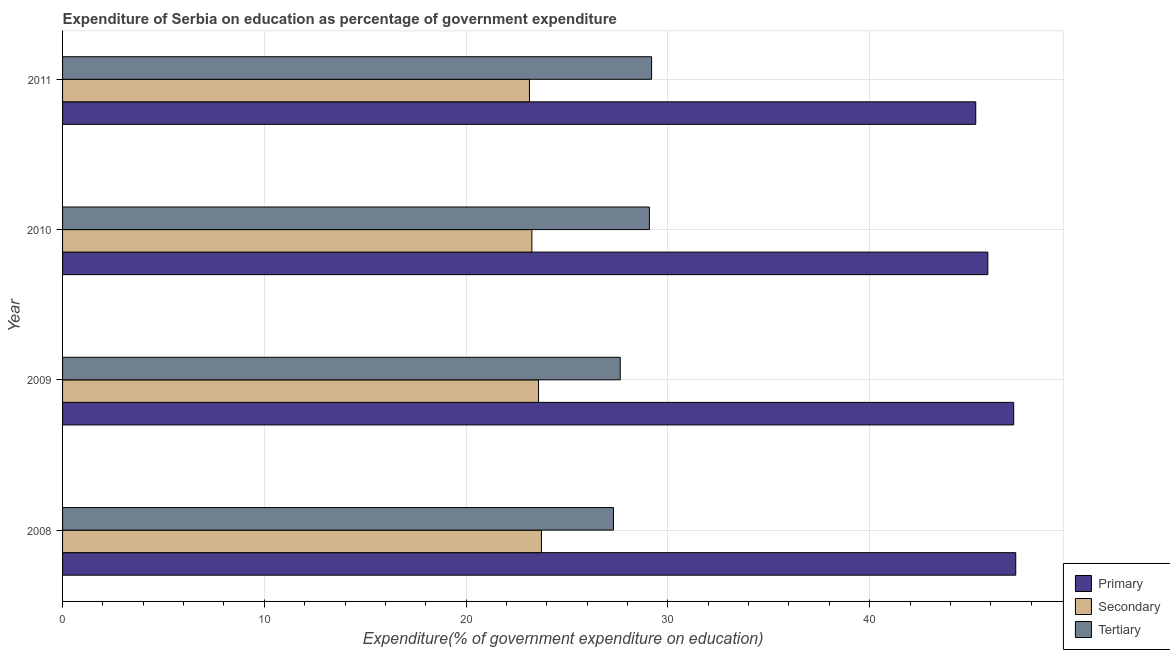How many different coloured bars are there?
Offer a terse response. 3. Are the number of bars per tick equal to the number of legend labels?
Keep it short and to the point. Yes. Are the number of bars on each tick of the Y-axis equal?
Ensure brevity in your answer.  Yes. How many bars are there on the 2nd tick from the top?
Ensure brevity in your answer.  3. How many bars are there on the 2nd tick from the bottom?
Your answer should be very brief. 3. In how many cases, is the number of bars for a given year not equal to the number of legend labels?
Your answer should be very brief. 0. What is the expenditure on tertiary education in 2008?
Your answer should be very brief. 27.3. Across all years, what is the maximum expenditure on tertiary education?
Provide a succinct answer. 29.19. Across all years, what is the minimum expenditure on secondary education?
Offer a terse response. 23.14. In which year was the expenditure on secondary education minimum?
Your response must be concise. 2011. What is the total expenditure on tertiary education in the graph?
Make the answer very short. 113.21. What is the difference between the expenditure on secondary education in 2009 and that in 2011?
Your answer should be very brief. 0.45. What is the difference between the expenditure on tertiary education in 2008 and the expenditure on secondary education in 2011?
Provide a succinct answer. 4.16. What is the average expenditure on tertiary education per year?
Offer a terse response. 28.3. In the year 2009, what is the difference between the expenditure on primary education and expenditure on secondary education?
Give a very brief answer. 23.55. What is the ratio of the expenditure on primary education in 2010 to that in 2011?
Your answer should be compact. 1.01. Is the expenditure on secondary education in 2008 less than that in 2009?
Offer a very short reply. No. What is the difference between the highest and the second highest expenditure on secondary education?
Give a very brief answer. 0.14. What is the difference between the highest and the lowest expenditure on tertiary education?
Offer a very short reply. 1.89. What does the 1st bar from the top in 2011 represents?
Your answer should be very brief. Tertiary. What does the 3rd bar from the bottom in 2010 represents?
Ensure brevity in your answer.  Tertiary. Is it the case that in every year, the sum of the expenditure on primary education and expenditure on secondary education is greater than the expenditure on tertiary education?
Provide a short and direct response. Yes. Are all the bars in the graph horizontal?
Provide a short and direct response. Yes. Does the graph contain any zero values?
Give a very brief answer. No. Does the graph contain grids?
Your response must be concise. Yes. Where does the legend appear in the graph?
Give a very brief answer. Bottom right. How many legend labels are there?
Give a very brief answer. 3. How are the legend labels stacked?
Offer a terse response. Vertical. What is the title of the graph?
Provide a succinct answer. Expenditure of Serbia on education as percentage of government expenditure. What is the label or title of the X-axis?
Your answer should be compact. Expenditure(% of government expenditure on education). What is the label or title of the Y-axis?
Your answer should be very brief. Year. What is the Expenditure(% of government expenditure on education) of Primary in 2008?
Provide a succinct answer. 47.24. What is the Expenditure(% of government expenditure on education) in Secondary in 2008?
Your response must be concise. 23.73. What is the Expenditure(% of government expenditure on education) of Tertiary in 2008?
Make the answer very short. 27.3. What is the Expenditure(% of government expenditure on education) in Primary in 2009?
Give a very brief answer. 47.14. What is the Expenditure(% of government expenditure on education) of Secondary in 2009?
Make the answer very short. 23.59. What is the Expenditure(% of government expenditure on education) in Tertiary in 2009?
Make the answer very short. 27.64. What is the Expenditure(% of government expenditure on education) in Primary in 2010?
Provide a short and direct response. 45.86. What is the Expenditure(% of government expenditure on education) in Secondary in 2010?
Provide a succinct answer. 23.26. What is the Expenditure(% of government expenditure on education) in Tertiary in 2010?
Your response must be concise. 29.08. What is the Expenditure(% of government expenditure on education) in Primary in 2011?
Make the answer very short. 45.26. What is the Expenditure(% of government expenditure on education) in Secondary in 2011?
Give a very brief answer. 23.14. What is the Expenditure(% of government expenditure on education) of Tertiary in 2011?
Your answer should be compact. 29.19. Across all years, what is the maximum Expenditure(% of government expenditure on education) in Primary?
Give a very brief answer. 47.24. Across all years, what is the maximum Expenditure(% of government expenditure on education) of Secondary?
Ensure brevity in your answer.  23.73. Across all years, what is the maximum Expenditure(% of government expenditure on education) in Tertiary?
Provide a succinct answer. 29.19. Across all years, what is the minimum Expenditure(% of government expenditure on education) of Primary?
Ensure brevity in your answer.  45.26. Across all years, what is the minimum Expenditure(% of government expenditure on education) in Secondary?
Make the answer very short. 23.14. Across all years, what is the minimum Expenditure(% of government expenditure on education) of Tertiary?
Give a very brief answer. 27.3. What is the total Expenditure(% of government expenditure on education) in Primary in the graph?
Ensure brevity in your answer.  185.49. What is the total Expenditure(% of government expenditure on education) of Secondary in the graph?
Ensure brevity in your answer.  93.72. What is the total Expenditure(% of government expenditure on education) of Tertiary in the graph?
Your response must be concise. 113.21. What is the difference between the Expenditure(% of government expenditure on education) in Primary in 2008 and that in 2009?
Offer a very short reply. 0.1. What is the difference between the Expenditure(% of government expenditure on education) in Secondary in 2008 and that in 2009?
Provide a succinct answer. 0.14. What is the difference between the Expenditure(% of government expenditure on education) in Tertiary in 2008 and that in 2009?
Your answer should be compact. -0.34. What is the difference between the Expenditure(% of government expenditure on education) of Primary in 2008 and that in 2010?
Your answer should be compact. 1.38. What is the difference between the Expenditure(% of government expenditure on education) in Secondary in 2008 and that in 2010?
Provide a succinct answer. 0.47. What is the difference between the Expenditure(% of government expenditure on education) of Tertiary in 2008 and that in 2010?
Provide a short and direct response. -1.78. What is the difference between the Expenditure(% of government expenditure on education) in Primary in 2008 and that in 2011?
Give a very brief answer. 1.98. What is the difference between the Expenditure(% of government expenditure on education) in Secondary in 2008 and that in 2011?
Provide a succinct answer. 0.59. What is the difference between the Expenditure(% of government expenditure on education) in Tertiary in 2008 and that in 2011?
Your answer should be very brief. -1.89. What is the difference between the Expenditure(% of government expenditure on education) in Primary in 2009 and that in 2010?
Provide a succinct answer. 1.28. What is the difference between the Expenditure(% of government expenditure on education) in Secondary in 2009 and that in 2010?
Your response must be concise. 0.33. What is the difference between the Expenditure(% of government expenditure on education) in Tertiary in 2009 and that in 2010?
Keep it short and to the point. -1.44. What is the difference between the Expenditure(% of government expenditure on education) of Primary in 2009 and that in 2011?
Provide a succinct answer. 1.88. What is the difference between the Expenditure(% of government expenditure on education) of Secondary in 2009 and that in 2011?
Offer a very short reply. 0.45. What is the difference between the Expenditure(% of government expenditure on education) of Tertiary in 2009 and that in 2011?
Your answer should be very brief. -1.55. What is the difference between the Expenditure(% of government expenditure on education) in Primary in 2010 and that in 2011?
Your answer should be very brief. 0.6. What is the difference between the Expenditure(% of government expenditure on education) in Secondary in 2010 and that in 2011?
Provide a short and direct response. 0.12. What is the difference between the Expenditure(% of government expenditure on education) of Tertiary in 2010 and that in 2011?
Provide a succinct answer. -0.11. What is the difference between the Expenditure(% of government expenditure on education) in Primary in 2008 and the Expenditure(% of government expenditure on education) in Secondary in 2009?
Provide a short and direct response. 23.65. What is the difference between the Expenditure(% of government expenditure on education) of Primary in 2008 and the Expenditure(% of government expenditure on education) of Tertiary in 2009?
Keep it short and to the point. 19.6. What is the difference between the Expenditure(% of government expenditure on education) of Secondary in 2008 and the Expenditure(% of government expenditure on education) of Tertiary in 2009?
Your answer should be very brief. -3.91. What is the difference between the Expenditure(% of government expenditure on education) in Primary in 2008 and the Expenditure(% of government expenditure on education) in Secondary in 2010?
Offer a very short reply. 23.98. What is the difference between the Expenditure(% of government expenditure on education) in Primary in 2008 and the Expenditure(% of government expenditure on education) in Tertiary in 2010?
Make the answer very short. 18.16. What is the difference between the Expenditure(% of government expenditure on education) of Secondary in 2008 and the Expenditure(% of government expenditure on education) of Tertiary in 2010?
Offer a very short reply. -5.35. What is the difference between the Expenditure(% of government expenditure on education) of Primary in 2008 and the Expenditure(% of government expenditure on education) of Secondary in 2011?
Your response must be concise. 24.1. What is the difference between the Expenditure(% of government expenditure on education) in Primary in 2008 and the Expenditure(% of government expenditure on education) in Tertiary in 2011?
Ensure brevity in your answer.  18.05. What is the difference between the Expenditure(% of government expenditure on education) of Secondary in 2008 and the Expenditure(% of government expenditure on education) of Tertiary in 2011?
Give a very brief answer. -5.46. What is the difference between the Expenditure(% of government expenditure on education) in Primary in 2009 and the Expenditure(% of government expenditure on education) in Secondary in 2010?
Provide a succinct answer. 23.88. What is the difference between the Expenditure(% of government expenditure on education) in Primary in 2009 and the Expenditure(% of government expenditure on education) in Tertiary in 2010?
Give a very brief answer. 18.05. What is the difference between the Expenditure(% of government expenditure on education) of Secondary in 2009 and the Expenditure(% of government expenditure on education) of Tertiary in 2010?
Offer a terse response. -5.49. What is the difference between the Expenditure(% of government expenditure on education) of Primary in 2009 and the Expenditure(% of government expenditure on education) of Secondary in 2011?
Offer a very short reply. 24. What is the difference between the Expenditure(% of government expenditure on education) of Primary in 2009 and the Expenditure(% of government expenditure on education) of Tertiary in 2011?
Offer a very short reply. 17.95. What is the difference between the Expenditure(% of government expenditure on education) in Secondary in 2009 and the Expenditure(% of government expenditure on education) in Tertiary in 2011?
Your answer should be compact. -5.6. What is the difference between the Expenditure(% of government expenditure on education) in Primary in 2010 and the Expenditure(% of government expenditure on education) in Secondary in 2011?
Your answer should be very brief. 22.72. What is the difference between the Expenditure(% of government expenditure on education) in Primary in 2010 and the Expenditure(% of government expenditure on education) in Tertiary in 2011?
Your answer should be compact. 16.66. What is the difference between the Expenditure(% of government expenditure on education) in Secondary in 2010 and the Expenditure(% of government expenditure on education) in Tertiary in 2011?
Offer a very short reply. -5.93. What is the average Expenditure(% of government expenditure on education) of Primary per year?
Ensure brevity in your answer.  46.37. What is the average Expenditure(% of government expenditure on education) in Secondary per year?
Keep it short and to the point. 23.43. What is the average Expenditure(% of government expenditure on education) in Tertiary per year?
Keep it short and to the point. 28.3. In the year 2008, what is the difference between the Expenditure(% of government expenditure on education) in Primary and Expenditure(% of government expenditure on education) in Secondary?
Your answer should be compact. 23.51. In the year 2008, what is the difference between the Expenditure(% of government expenditure on education) in Primary and Expenditure(% of government expenditure on education) in Tertiary?
Your response must be concise. 19.94. In the year 2008, what is the difference between the Expenditure(% of government expenditure on education) in Secondary and Expenditure(% of government expenditure on education) in Tertiary?
Offer a terse response. -3.57. In the year 2009, what is the difference between the Expenditure(% of government expenditure on education) of Primary and Expenditure(% of government expenditure on education) of Secondary?
Ensure brevity in your answer.  23.55. In the year 2009, what is the difference between the Expenditure(% of government expenditure on education) in Primary and Expenditure(% of government expenditure on education) in Tertiary?
Give a very brief answer. 19.5. In the year 2009, what is the difference between the Expenditure(% of government expenditure on education) of Secondary and Expenditure(% of government expenditure on education) of Tertiary?
Keep it short and to the point. -4.05. In the year 2010, what is the difference between the Expenditure(% of government expenditure on education) in Primary and Expenditure(% of government expenditure on education) in Secondary?
Offer a very short reply. 22.6. In the year 2010, what is the difference between the Expenditure(% of government expenditure on education) in Primary and Expenditure(% of government expenditure on education) in Tertiary?
Provide a short and direct response. 16.77. In the year 2010, what is the difference between the Expenditure(% of government expenditure on education) in Secondary and Expenditure(% of government expenditure on education) in Tertiary?
Give a very brief answer. -5.82. In the year 2011, what is the difference between the Expenditure(% of government expenditure on education) in Primary and Expenditure(% of government expenditure on education) in Secondary?
Your answer should be very brief. 22.12. In the year 2011, what is the difference between the Expenditure(% of government expenditure on education) of Primary and Expenditure(% of government expenditure on education) of Tertiary?
Your response must be concise. 16.07. In the year 2011, what is the difference between the Expenditure(% of government expenditure on education) in Secondary and Expenditure(% of government expenditure on education) in Tertiary?
Keep it short and to the point. -6.05. What is the ratio of the Expenditure(% of government expenditure on education) of Primary in 2008 to that in 2009?
Give a very brief answer. 1. What is the ratio of the Expenditure(% of government expenditure on education) of Primary in 2008 to that in 2010?
Provide a succinct answer. 1.03. What is the ratio of the Expenditure(% of government expenditure on education) of Secondary in 2008 to that in 2010?
Your answer should be very brief. 1.02. What is the ratio of the Expenditure(% of government expenditure on education) of Tertiary in 2008 to that in 2010?
Offer a very short reply. 0.94. What is the ratio of the Expenditure(% of government expenditure on education) in Primary in 2008 to that in 2011?
Your answer should be very brief. 1.04. What is the ratio of the Expenditure(% of government expenditure on education) of Secondary in 2008 to that in 2011?
Make the answer very short. 1.03. What is the ratio of the Expenditure(% of government expenditure on education) in Tertiary in 2008 to that in 2011?
Ensure brevity in your answer.  0.94. What is the ratio of the Expenditure(% of government expenditure on education) in Primary in 2009 to that in 2010?
Offer a very short reply. 1.03. What is the ratio of the Expenditure(% of government expenditure on education) of Secondary in 2009 to that in 2010?
Provide a succinct answer. 1.01. What is the ratio of the Expenditure(% of government expenditure on education) in Tertiary in 2009 to that in 2010?
Offer a terse response. 0.95. What is the ratio of the Expenditure(% of government expenditure on education) of Primary in 2009 to that in 2011?
Your answer should be very brief. 1.04. What is the ratio of the Expenditure(% of government expenditure on education) of Secondary in 2009 to that in 2011?
Your response must be concise. 1.02. What is the ratio of the Expenditure(% of government expenditure on education) in Tertiary in 2009 to that in 2011?
Provide a short and direct response. 0.95. What is the ratio of the Expenditure(% of government expenditure on education) of Primary in 2010 to that in 2011?
Your response must be concise. 1.01. What is the ratio of the Expenditure(% of government expenditure on education) of Secondary in 2010 to that in 2011?
Keep it short and to the point. 1.01. What is the difference between the highest and the second highest Expenditure(% of government expenditure on education) of Primary?
Offer a very short reply. 0.1. What is the difference between the highest and the second highest Expenditure(% of government expenditure on education) in Secondary?
Your answer should be very brief. 0.14. What is the difference between the highest and the second highest Expenditure(% of government expenditure on education) in Tertiary?
Provide a succinct answer. 0.11. What is the difference between the highest and the lowest Expenditure(% of government expenditure on education) of Primary?
Provide a succinct answer. 1.98. What is the difference between the highest and the lowest Expenditure(% of government expenditure on education) in Secondary?
Your answer should be compact. 0.59. What is the difference between the highest and the lowest Expenditure(% of government expenditure on education) in Tertiary?
Give a very brief answer. 1.89. 